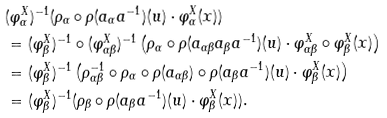<formula> <loc_0><loc_0><loc_500><loc_500>& ( \varphi ^ { X } _ { \alpha } ) ^ { - 1 } ( \rho _ { \alpha } \circ \rho ( a _ { \alpha } a ^ { - 1 } ) ( u ) \cdot \varphi ^ { X } _ { \alpha } ( x ) ) \\ & = ( \varphi ^ { X } _ { \beta } ) ^ { - 1 } \circ ( \varphi ^ { X } _ { \alpha \beta } ) ^ { - 1 } \left ( \rho _ { \alpha } \circ \rho ( a _ { \alpha \beta } a _ { \beta } a ^ { - 1 } ) ( u ) \cdot \varphi ^ { X } _ { \alpha \beta } \circ \varphi ^ { X } _ { \beta } ( x ) \right ) \\ & = ( \varphi ^ { X } _ { \beta } ) ^ { - 1 } \left ( \rho _ { \alpha \beta } ^ { - 1 } \circ \rho _ { \alpha } \circ \rho ( a _ { \alpha \beta } ) \circ \rho ( a _ { \beta } a ^ { - 1 } ) ( u ) \cdot \varphi ^ { X } _ { \beta } ( x ) \right ) \\ & = ( \varphi ^ { X } _ { \beta } ) ^ { - 1 } ( \rho _ { \beta } \circ \rho ( a _ { \beta } a ^ { - 1 } ) ( u ) \cdot \varphi ^ { X } _ { \beta } ( x ) ) .</formula> 